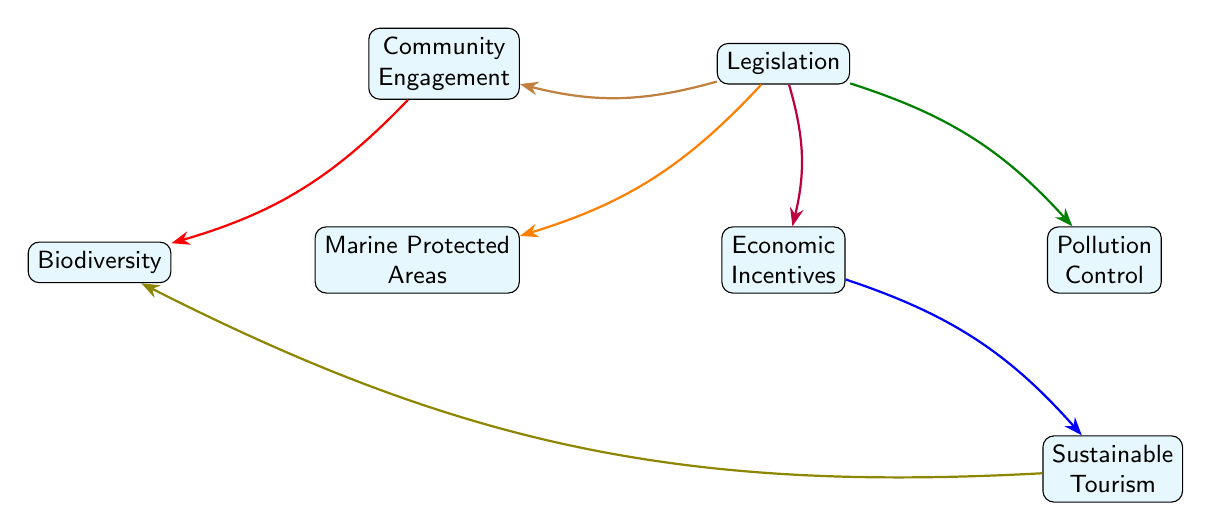What is the central node in the diagram? The central node in the diagram is "Legislation," which connects to various other nodes illustrating its influence in coastal area conservation efforts.
Answer: Legislation How many edges are there in the diagram? There are a total of seven edges connecting the central node "Legislation" to various other nodes, highlighting different relationships and influences.
Answer: 7 Which node is connected to "Legislation" with an edge labeled "Enables establishment"? The node connected to "Legislation" with the edge labeled "Enables establishment" is "Marine Protected Areas." This indicates that legislation allows for the creation of these areas.
Answer: Marine Protected Areas What type of relationship does "Legislation" have with "Community Engagement"? "Legislation" has a relationship with "Community Engagement" labeled as "Facilitates," indicating that legislation supports and helps to advance community involvement in conservation efforts.
Answer: Facilitates Which node is positively influenced by "Sustainable Tourism" according to the diagram? "Sustainable Tourism" supports the node "Biodiversity," indicating that efforts to promote sustainable tourism positively impact biodiversity conservation.
Answer: Biodiversity How does "Economic Incentives" interact with "Sustainable Tourism"? "Economic Incentives" promotes "Sustainable Tourism," which suggests that financial incentives lead to the development of tourism practices that are environmentally friendly and sustainable.
Answer: Promotes What is the indirect connection from "Legislation" to "Biodiversity"? The indirect connection from "Legislation" to "Biodiversity" goes through "Community Engagement" and is labeled "Enhances awareness." This indicates that the legislation encourages community involvement, which in turn raises awareness about biodiversity.
Answer: Enhances awareness Describe the flow of influence from "Legislation" to "Pollution Control." The flow of influence from "Legislation" to "Pollution Control" is labeled "Implements," indicating that legislation establishes frameworks or regulations aimed at controlling pollution in coastal areas.
Answer: Implements What is the overall theme represented in the diagram? The overall theme represents the influence of legislation on various factors related to coastal area conservation, highlighting how laws and policies can drive effective conservation strategies.
Answer: Legislation's influence on conservation 